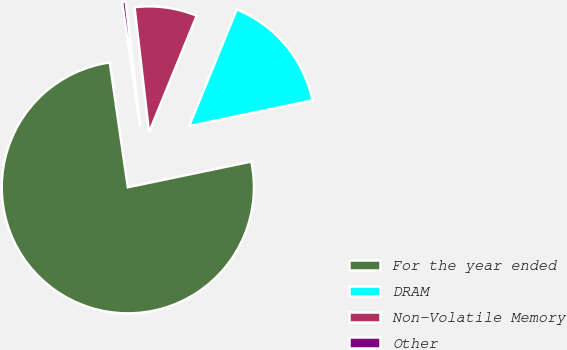Convert chart to OTSL. <chart><loc_0><loc_0><loc_500><loc_500><pie_chart><fcel>For the year ended<fcel>DRAM<fcel>Non-Volatile Memory<fcel>Other<nl><fcel>75.98%<fcel>15.56%<fcel>8.01%<fcel>0.45%<nl></chart> 